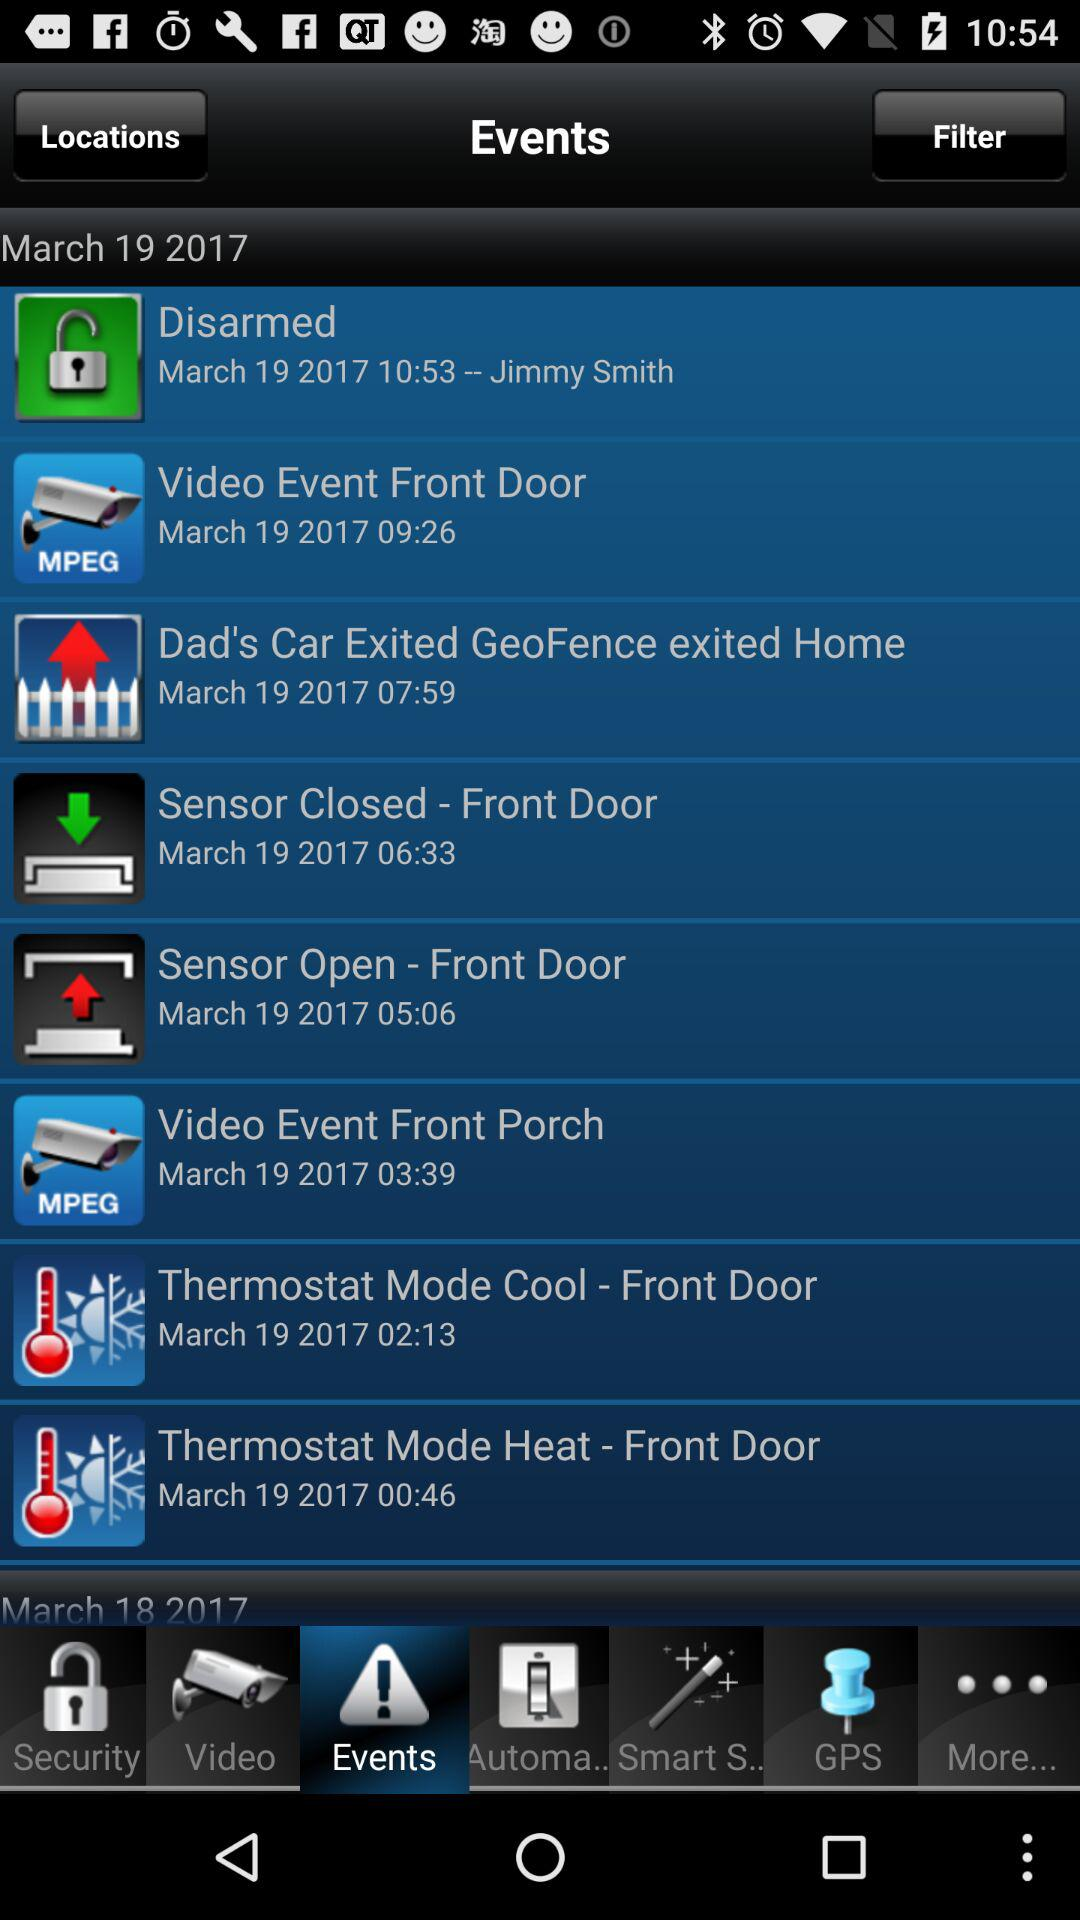At what time is the event "Video Event Front Door" scheduled? The event is scheduled for March 19, 2017. 